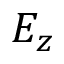<formula> <loc_0><loc_0><loc_500><loc_500>E _ { z }</formula> 